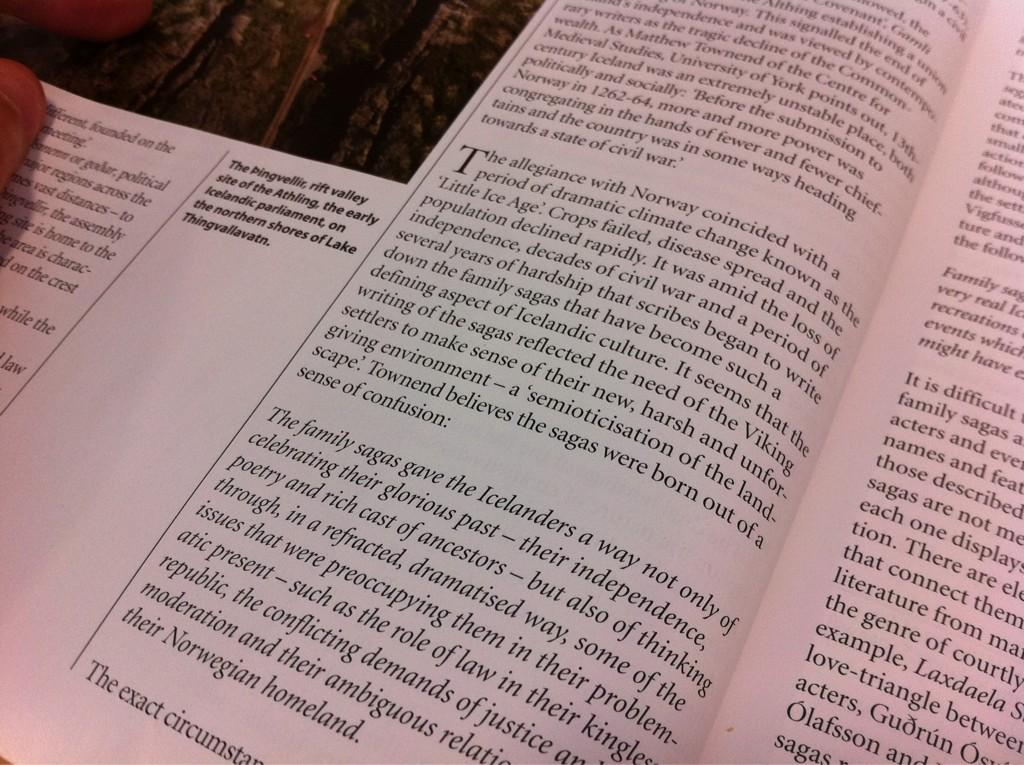<image>
Present a compact description of the photo's key features. A book shows a cut off picture of the Pingvellir, rift valley site of the Athling 